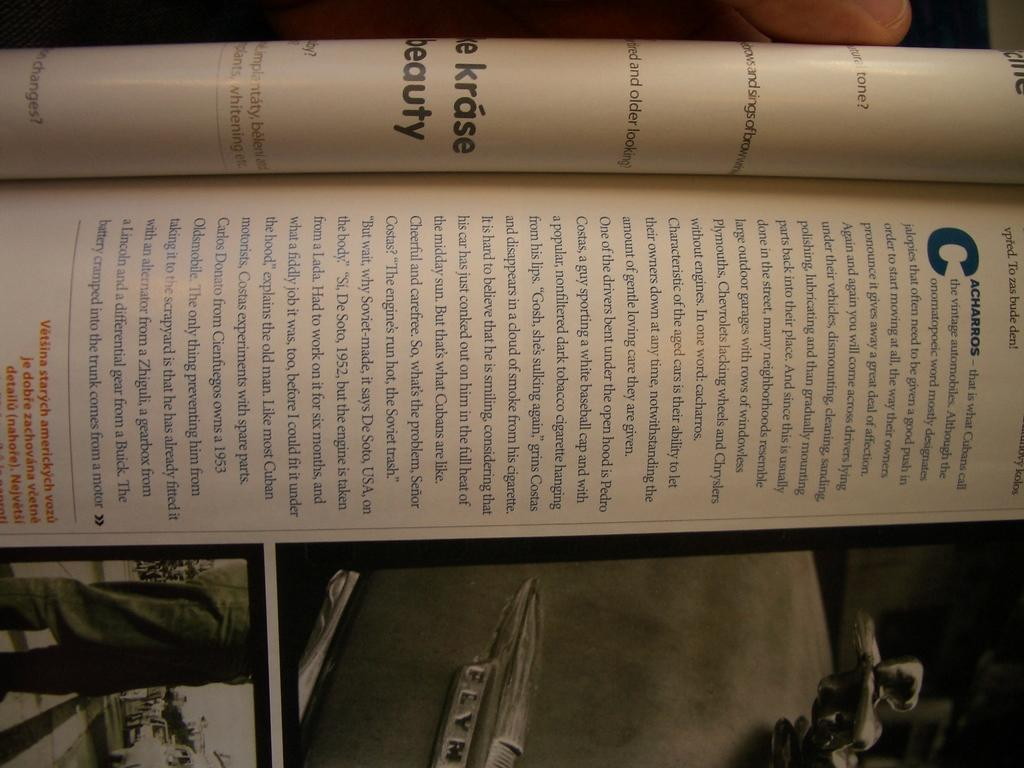<image>
Summarize the visual content of the image. A sideways on snapshot of a magazine, the writing in which is too small to read. 